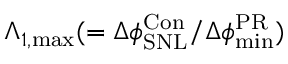<formula> <loc_0><loc_0><loc_500><loc_500>\Lambda _ { 1 , { \max } } ( = \Delta \phi _ { S N L } ^ { C o n } / \Delta \phi _ { \min } ^ { P R } )</formula> 